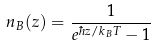<formula> <loc_0><loc_0><loc_500><loc_500>n _ { B } ( z ) = \frac { 1 } { e ^ { \hbar { z } / k _ { B } T } - 1 }</formula> 